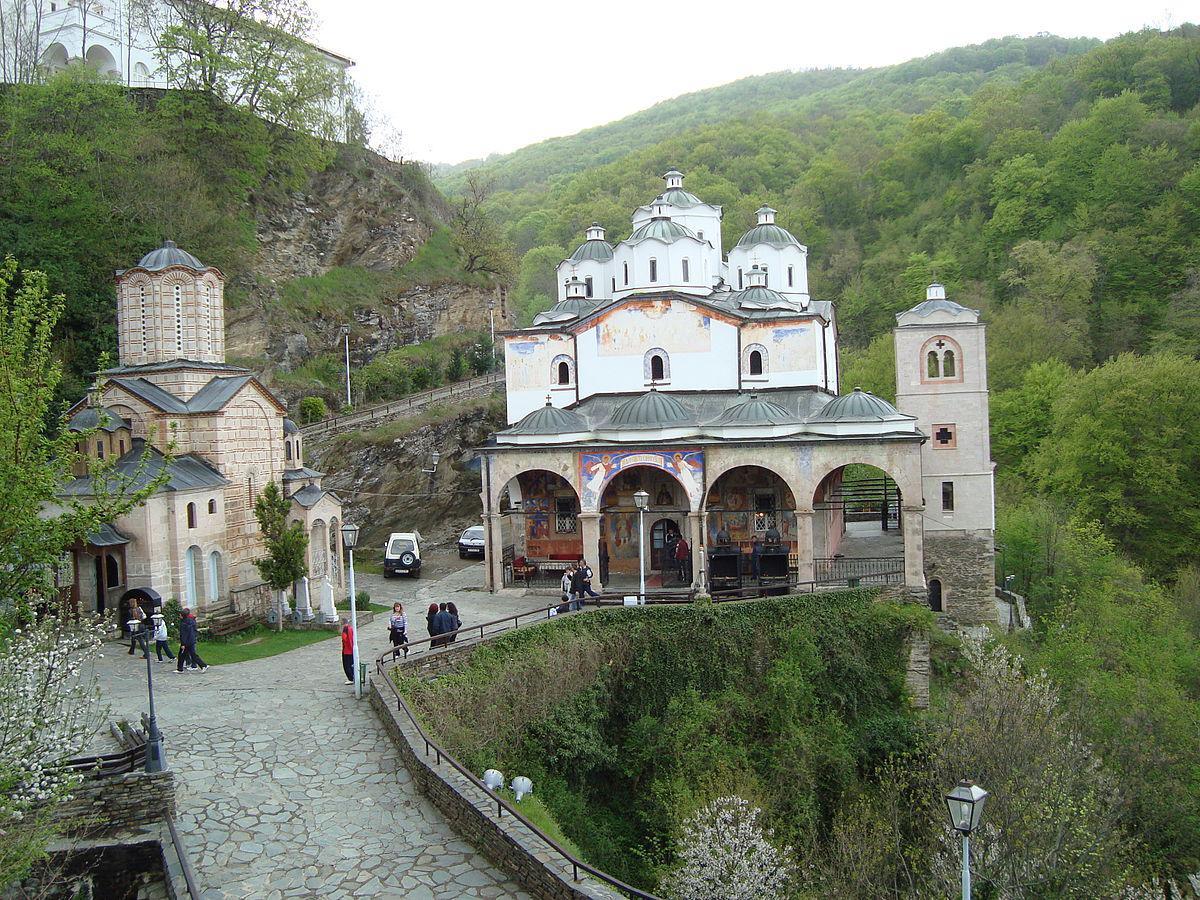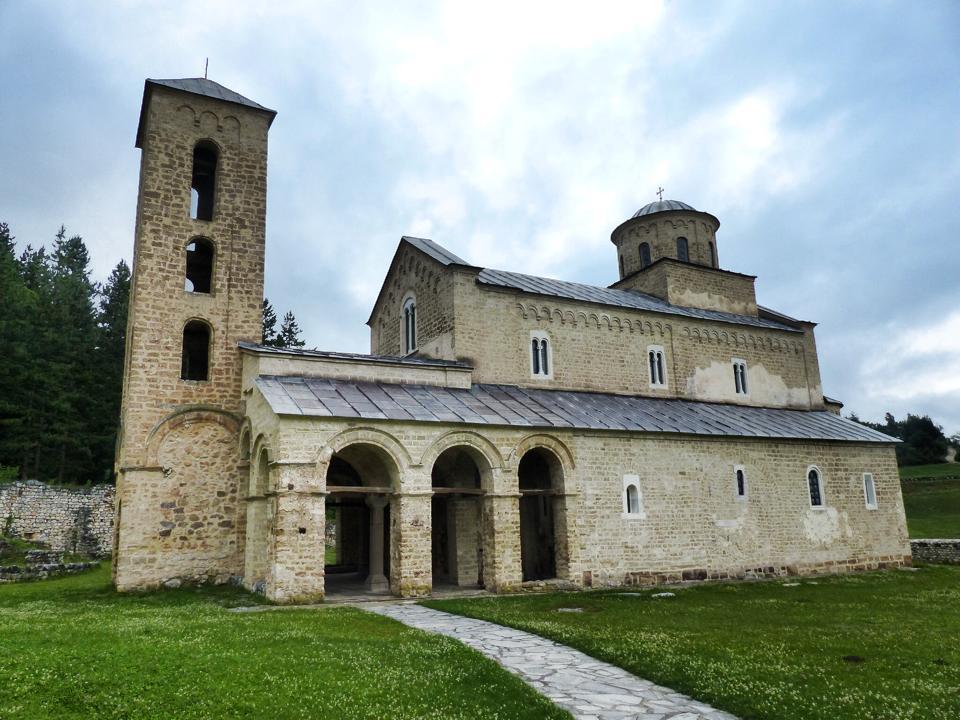The first image is the image on the left, the second image is the image on the right. For the images displayed, is the sentence "At least one image shows a sprawling building that includes a dark blue-gray cone roof on a cylindrical tower." factually correct? Answer yes or no. No. 